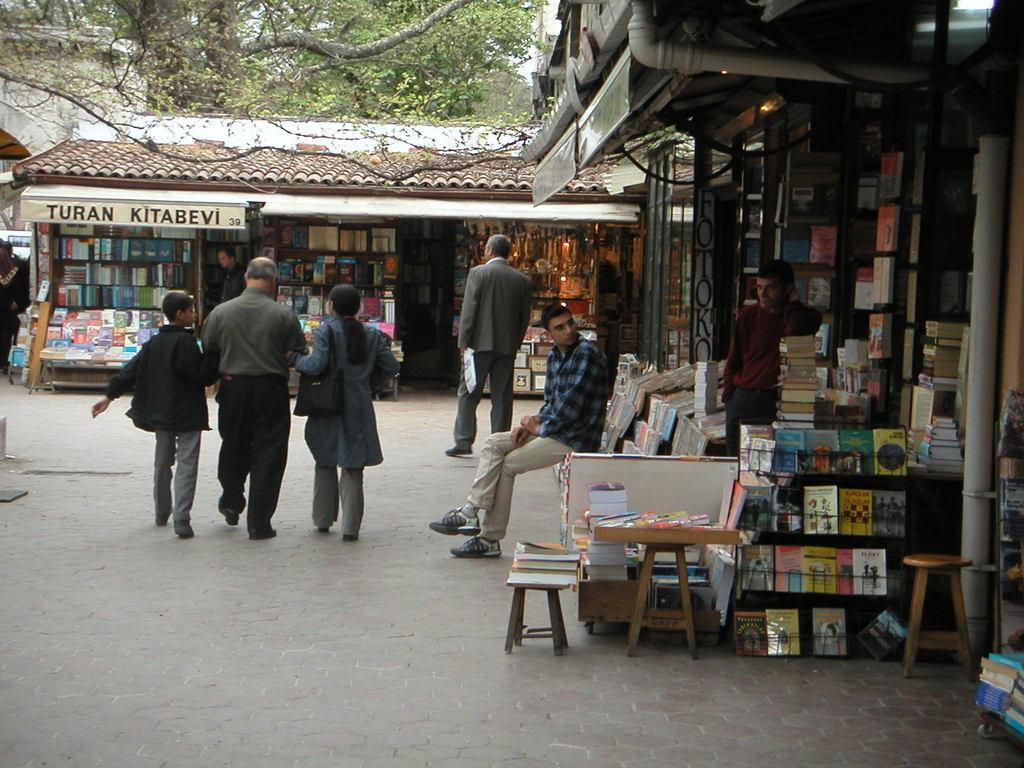Can you describe this image briefly? In this picture there are people in the center of the image and there are book stalls on the right and in the background area of the image, there are trees at the top side of the image. 